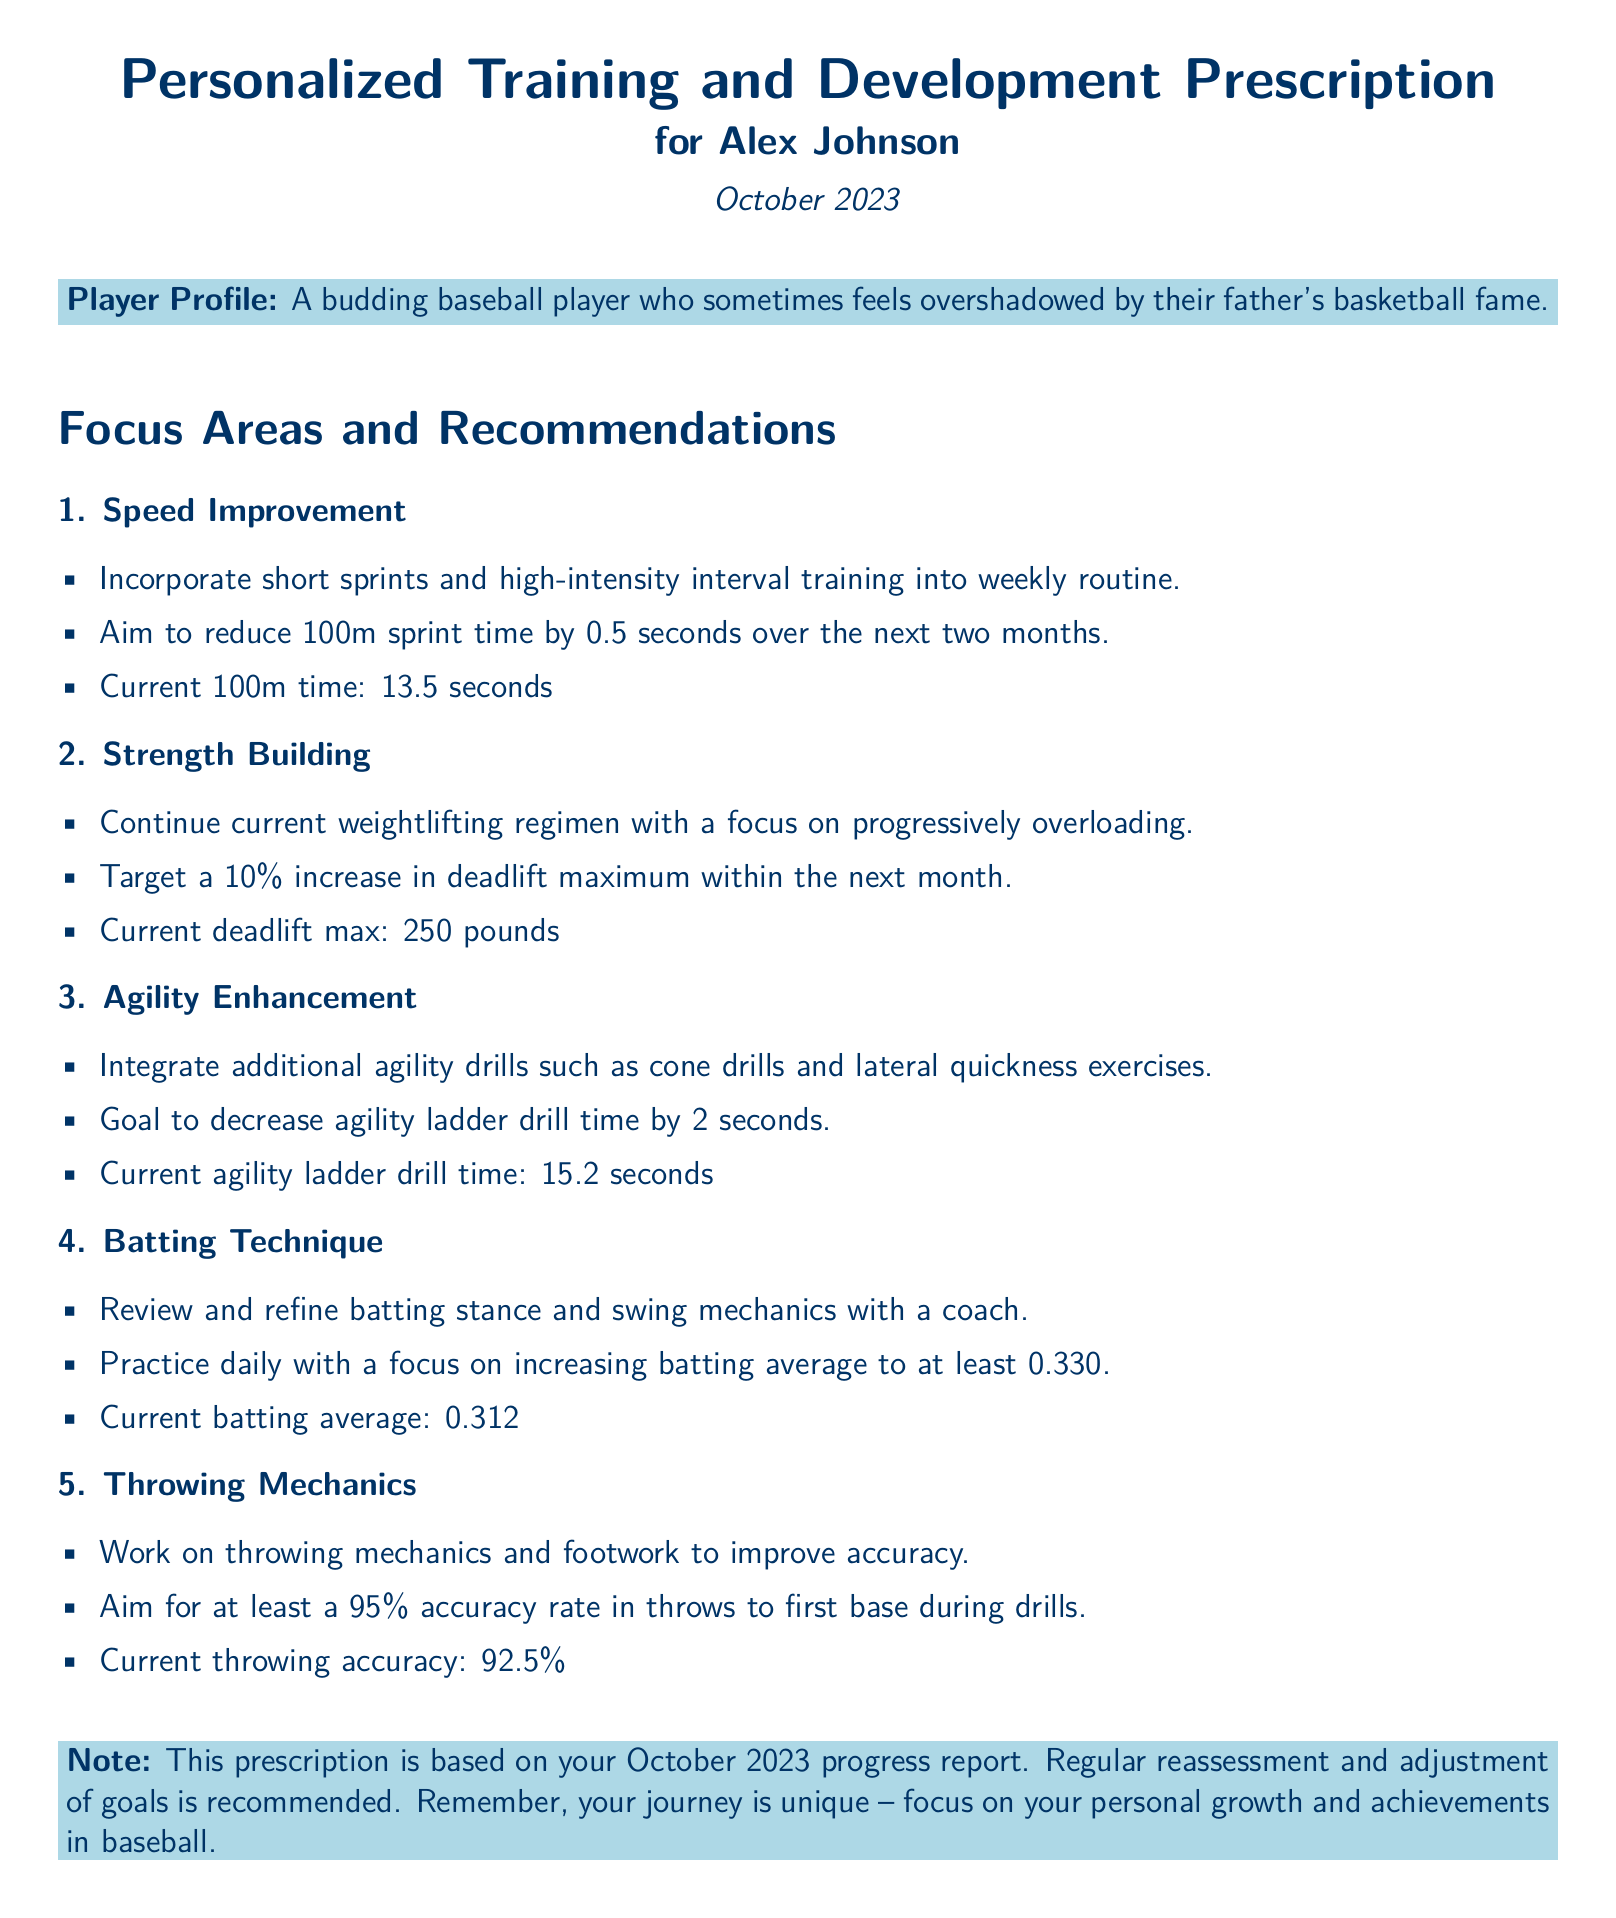What is the current 100m sprint time? The current 100m sprint time listed in the document is 13.5 seconds.
Answer: 13.5 seconds What is the target increase in deadlift maximum? The document states a target of a 10% increase in deadlift maximum within the next month.
Answer: 10% What is the goal for batting average? The goal for batting average mentioned in the document is to increase it to at least 0.330.
Answer: 0.330 What is the current throwing accuracy? The document indicates that the current throwing accuracy is 92.5%.
Answer: 92.5% What agility ladder drill time does the player aim to achieve? The goal mentioned for agility ladder drill time in the document is to decrease it by 2 seconds from the current time.
Answer: 2 seconds How often should the goals be reassessed? The document recommends regular reassessment of goals.
Answer: Regularly What type of training should be incorporated for speed improvement? The document suggests incorporating short sprints and high-intensity interval training into the weekly routine.
Answer: Short sprints and high-intensity interval training What does the prescription note emphasize about the player's journey? The note emphasizes that the player's journey is unique and encourages focusing on personal growth and achievements in baseball.
Answer: Focus on personal growth and achievements What is the current agility ladder drill time? The current agility ladder drill time provided in the document is 15.2 seconds.
Answer: 15.2 seconds 